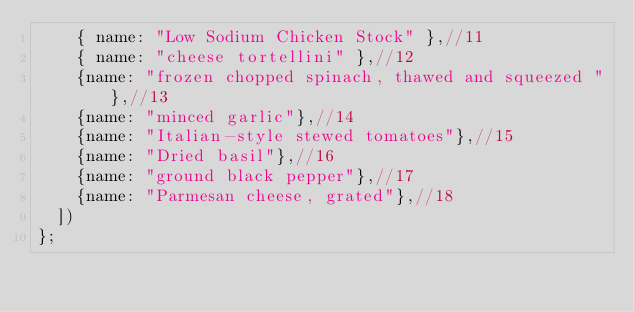<code> <loc_0><loc_0><loc_500><loc_500><_JavaScript_>    { name: "Low Sodium Chicken Stock" },//11
    { name: "cheese tortellini" },//12
    {name: "frozen chopped spinach, thawed and squeezed "},//13
    {name: "minced garlic"},//14
    {name: "Italian-style stewed tomatoes"},//15
    {name: "Dried basil"},//16
    {name: "ground black pepper"},//17
    {name: "Parmesan cheese, grated"},//18
  ])
};
</code> 